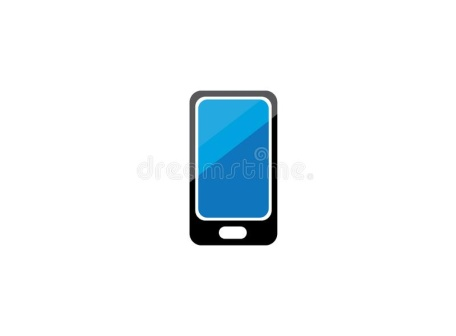Analyze the image in a comprehensive and detailed manner. The image features a sleek, modern smartphone prominently positioned in the center of a stark white background. The phone, which is black, is oriented vertically in portrait mode. Its screen, a vibrant blue, shines brightly without any icons or text, offering a clean and uncluttered display. The minimalist design includes a single white home button at the bottom center of the device, providing a subtle contrast to the black exterior. This contrast between the vivid blue screen and the black body of the phone against the white backdrop creates a visually striking composition. The lighting in the image accentuates this contrast with delicate shadows, enhancing the overall aesthetic. The focus is solely on the phone, emphasizing its elegant design and the advanced technology it represents. The image is static, capturing a moment of stillness and allowing viewers to appreciate the fine details and craftsmanship of the smartphone. 